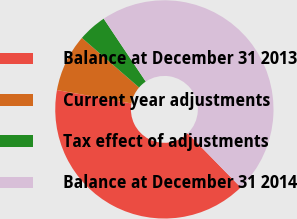Convert chart to OTSL. <chart><loc_0><loc_0><loc_500><loc_500><pie_chart><fcel>Balance at December 31 2013<fcel>Current year adjustments<fcel>Tax effect of adjustments<fcel>Balance at December 31 2014<nl><fcel>40.17%<fcel>8.53%<fcel>4.25%<fcel>47.05%<nl></chart> 